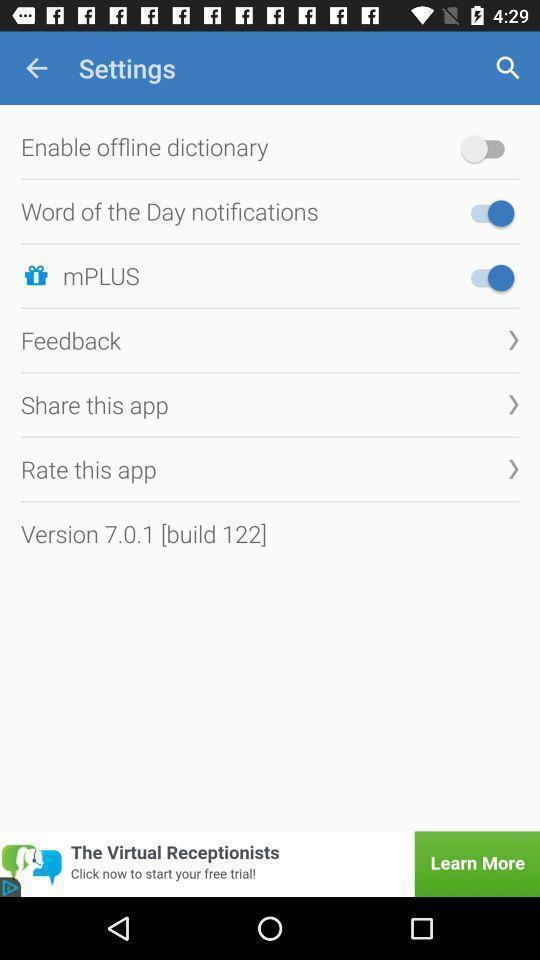Summarize the information in this screenshot. Settings page of a dictionary application. 